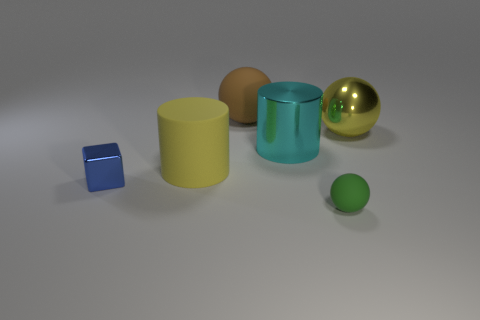Subtract all matte balls. How many balls are left? 1 Add 3 purple rubber cylinders. How many objects exist? 9 Subtract all cylinders. How many objects are left? 4 Subtract all tiny green spheres. Subtract all large spheres. How many objects are left? 3 Add 4 large brown things. How many large brown things are left? 5 Add 1 tiny matte balls. How many tiny matte balls exist? 2 Subtract 0 gray cylinders. How many objects are left? 6 